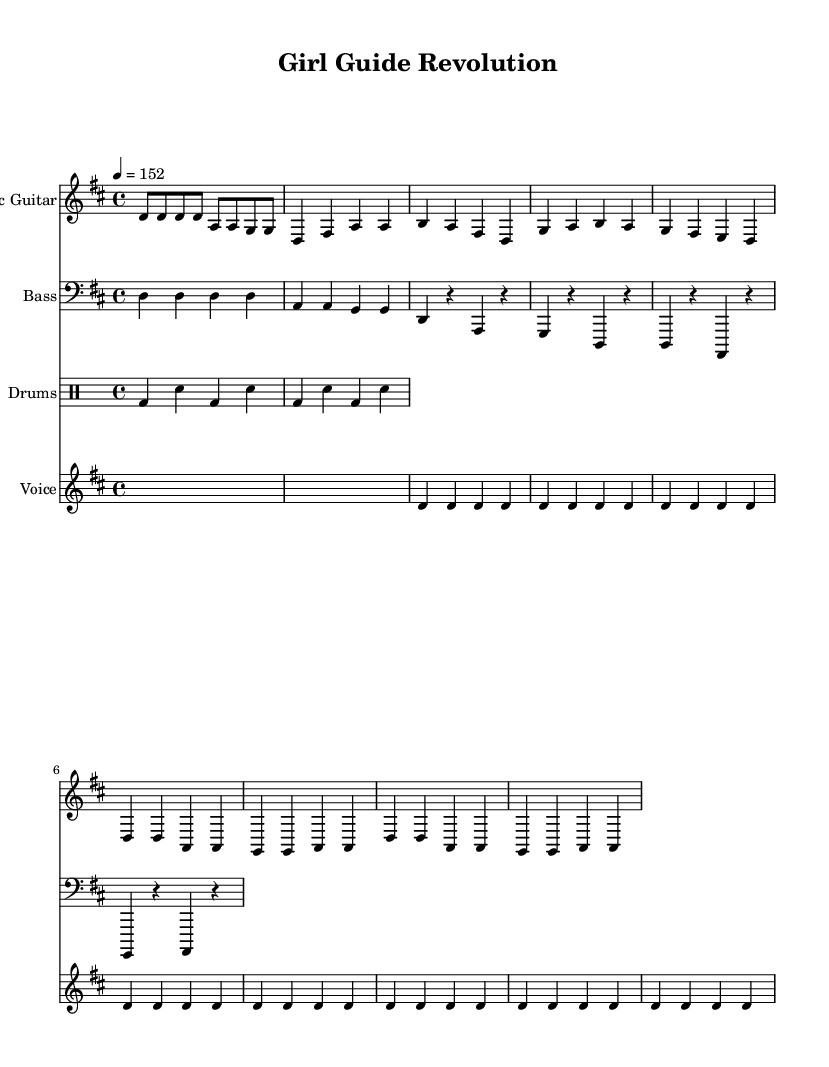What is the key signature of this music? The key signature is D major, indicated by the presence of two sharps (F# and C#) in the music.
Answer: D major What is the time signature of this piece? The time signature is 4/4, indicated at the beginning of the score, meaning there are four beats in a measure.
Answer: 4/4 What is the tempo marking of this music? The tempo marking indicates the piece should be played at a speed of 152 beats per minute, as shown under the tempo indication.
Answer: 152 How many measures are in the verse section? The verse section contains four measures as indicated by the number of bar lines before transitioning to the chorus.
Answer: 4 What instrument plays the bass part? The bass part is performed on the bass guitar, which is labeled in the score.
Answer: Bass How does the chorus differ from the verse in terms of lyrics? The chorus lyrics express unity and the fight for equality, contrasting with the verse that focuses on empowerment through action.
Answer: Unity and fight for equality What musical genre does the title "Girl Guide Revolution" imply? The title suggests a punk genre, as it combines themes of activism and empowerment, which are characteristic of punk music.
Answer: Punk 